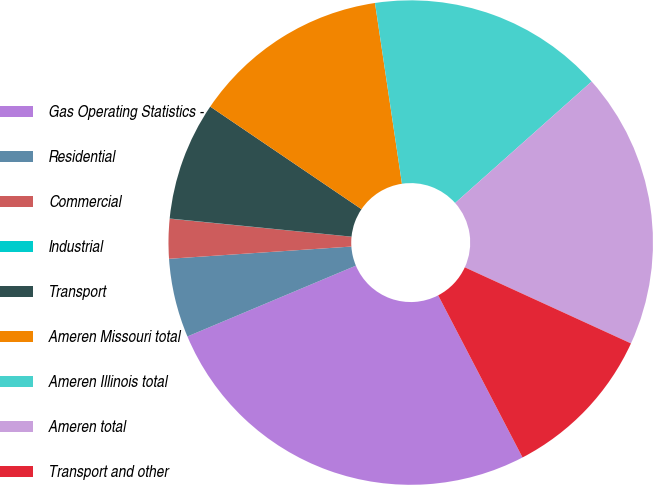<chart> <loc_0><loc_0><loc_500><loc_500><pie_chart><fcel>Gas Operating Statistics -<fcel>Residential<fcel>Commercial<fcel>Industrial<fcel>Transport<fcel>Ameren Missouri total<fcel>Ameren Illinois total<fcel>Ameren total<fcel>Transport and other<nl><fcel>26.3%<fcel>5.27%<fcel>2.64%<fcel>0.01%<fcel>7.9%<fcel>13.16%<fcel>15.78%<fcel>18.41%<fcel>10.53%<nl></chart> 